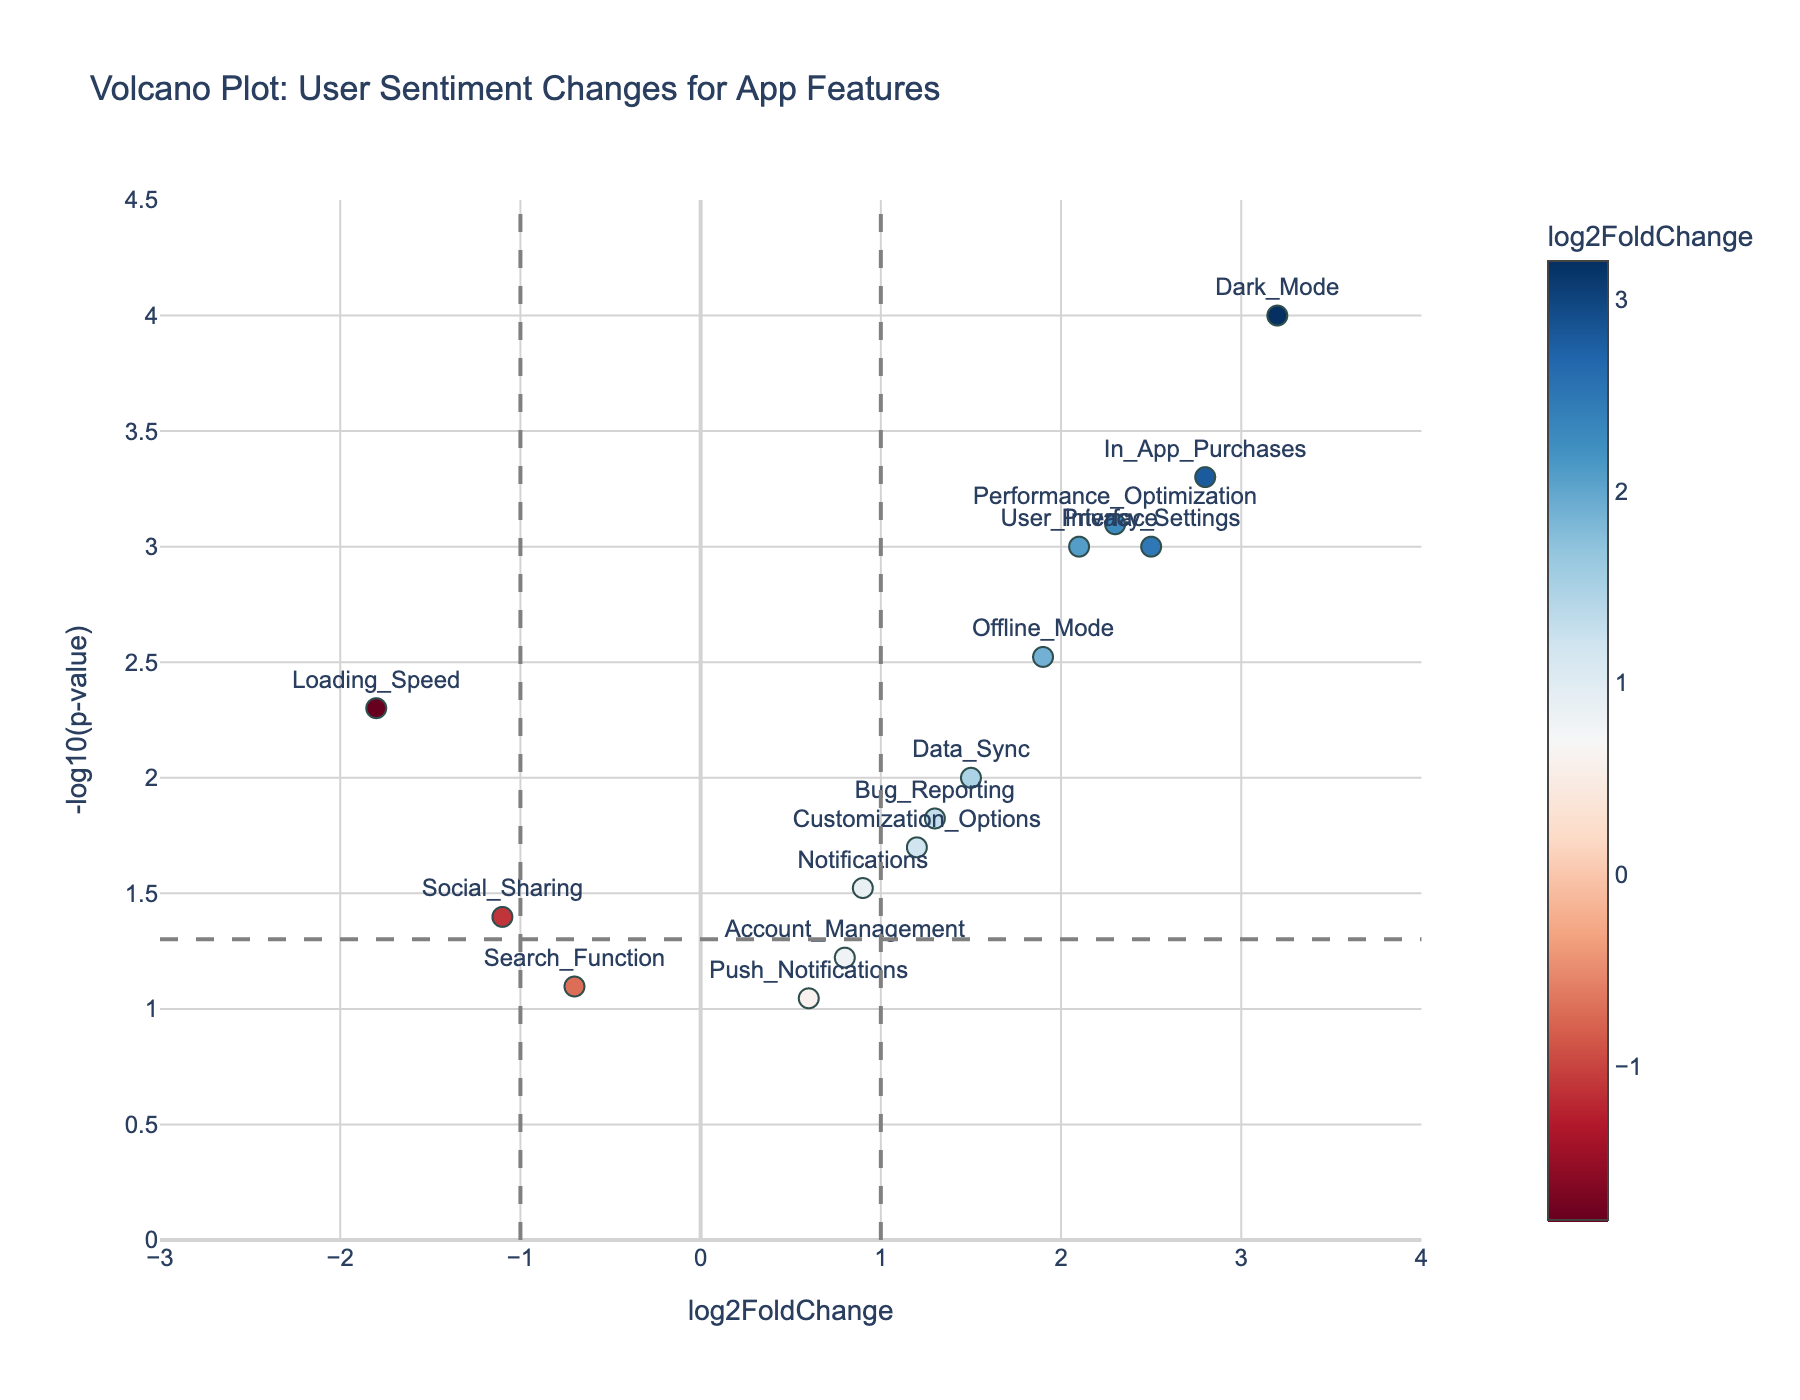How many features have a log2FoldChange greater than 2? To determine the number of features with a log2FoldChange greater than 2, look for those points on the plot that lie to the right of the vertical line at log2FoldChange = 2. These features are 'Dark_Mode', 'In_App_Purchases', 'Privacy_Settings', 'Performance_Optimization', and 'User_Interface'. Therefore, there are 5 such features.
Answer: 5 Which feature shows the highest significance based on p-value? The higher the -log10(p-value), the more significant the feature. On the y-axis, the highest point corresponds to 'Dark_Mode'.
Answer: Dark_Mode What is the log2FoldChange and -log10(p-value) for the Loading_Speed feature? To find the log2FoldChange and -log10(p-value) for 'Loading_Speed', locate the 'Loading_Speed' point on the plot. The log2FoldChange is -1.8 and the -log10(p-value) is -log10(0.005). Hence, -log10(0.005) is roughly 2.30.
Answer: -1.8 and 2.30 Compare the significance of Bug_Reporting and In_App_Purchases. Which one is higher? The significance is given by the -log10(p-value). Find both points on the plot and compare their y-values. The -log10(p-value) for 'Bug_Reporting' is around 1.82, and for 'In_App_Purchases', it's around 3.30. Therefore, 'In_App_Purchases' has higher significance.
Answer: In_App_Purchases Which two features have the lowest log2FoldChange and what are their respective p-values? The lowest log2FoldChange indicates the leftmost points on the plot. These are 'Loading_Speed' with a log2FoldChange of -1.8 and a p-value of 0.005, and 'Social_Sharing' with a log2FoldChange of -1.1 and a p-value of 0.04.
Answer: Loading_Speed (0.005) and Social_Sharing (0.04) How many features have significant p-values (p < 0.05) but log2FoldChange values less than 2? Significant p-values correspond to points above the horizontal line at y = -log10(0.05). Filter out features with log2FoldChange < 2 from these points. These points are 'Loading_Speed', 'Notifications', 'Data_Sync', 'Bug_Reporting', 'Customization_Options', 'Social_Sharing', 'Offline_Mode', and 'Account_Management'. There are 8 such features.
Answer: 8 Which feature has a log2FoldChange closest to 0 and what is its p-value? Identify the feature whose point is nearest to the vertical line at log2FoldChange = 0. The feature 'Push_Notifications' has a log2FoldChange of 0.6 and a p-value of 0.09, making it closest to 0.
Answer: Push_Notifications (0.09) What is the median -log10(p-value) of all features in the plot? To find the median -log10(p-value), list all -log10(p-values) and find the middle value. Converting p-values to -log10(p-value), the sorted list is approximately [0.93, 1.07, 1.22, 1.30, 1.47, 1.52, 1.7, 1.82, 2.00, 2.13, 2.30, 2.5, 3.00, 3.10, 4.0], the median value (middle of sorted list) is around 1.52.
Answer: 1.52 